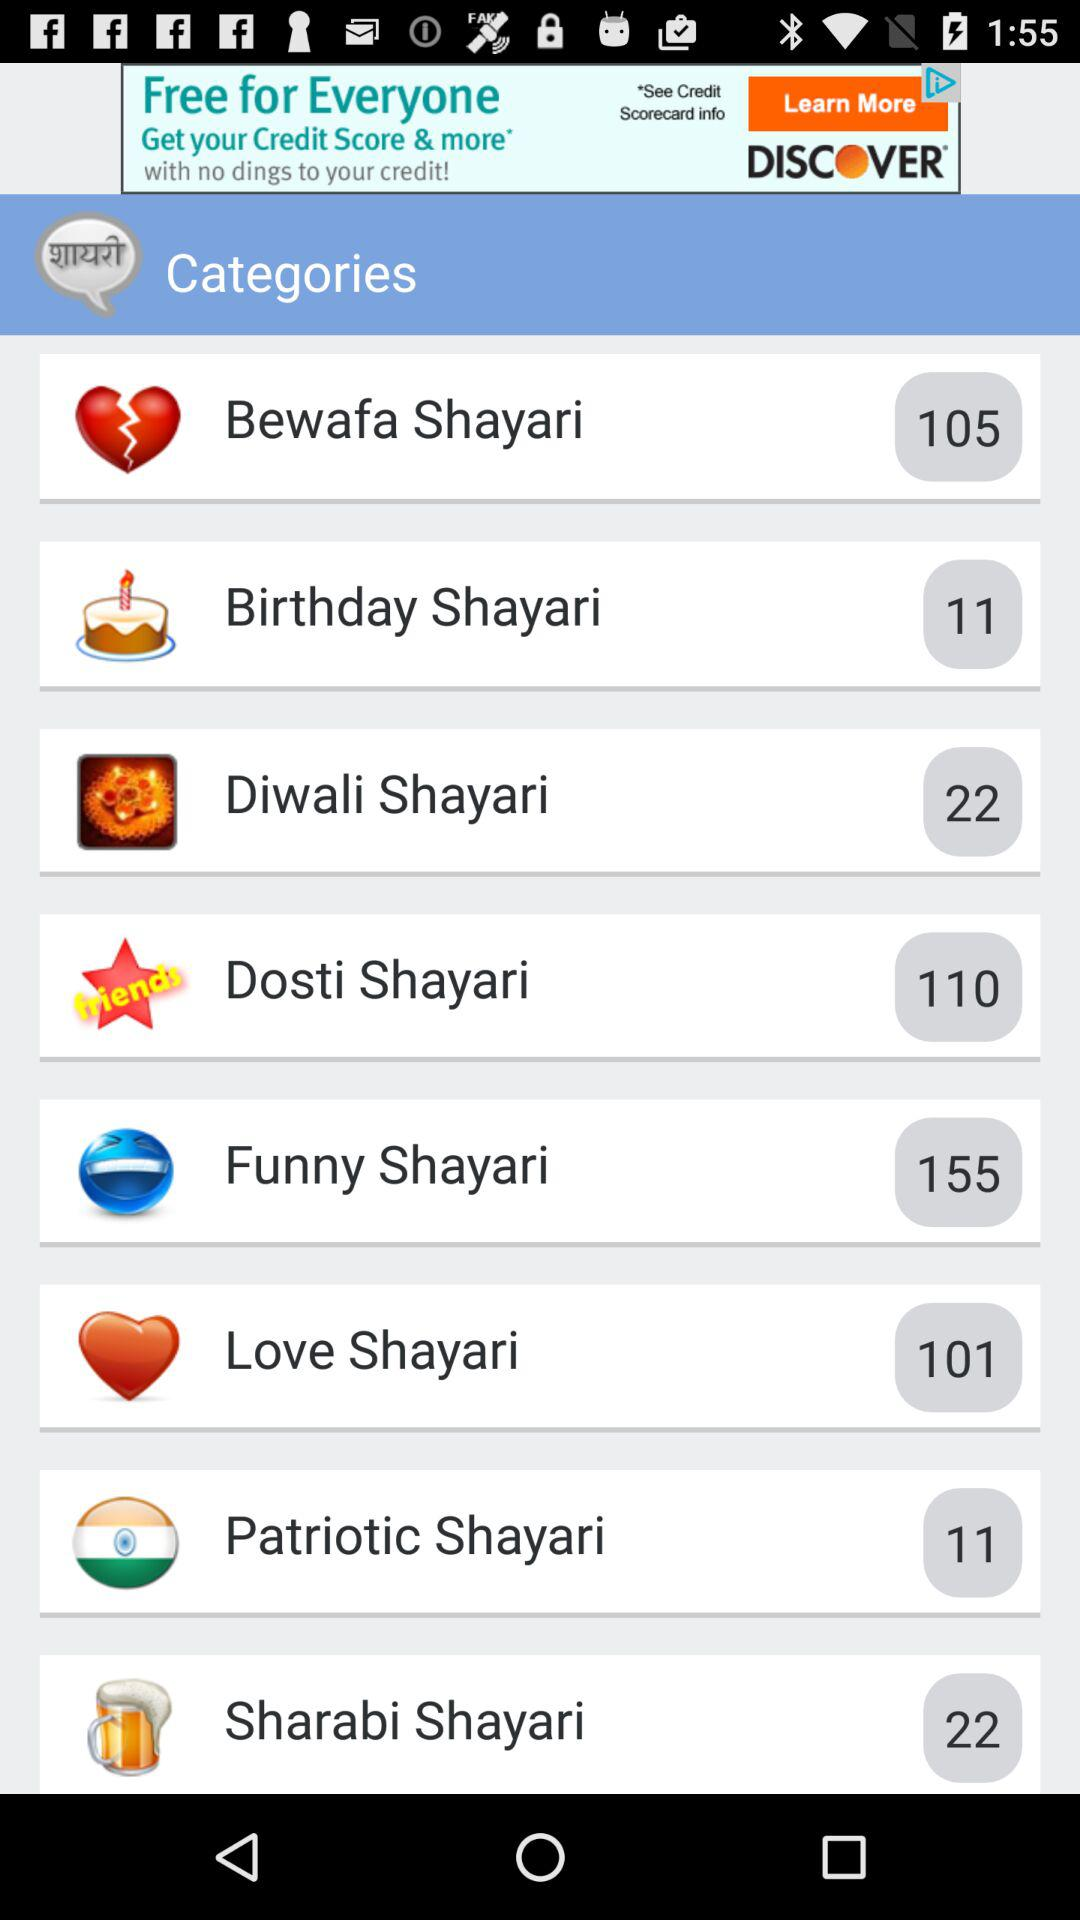What is the name of the application?
When the provided information is insufficient, respond with <no answer>. <no answer> 